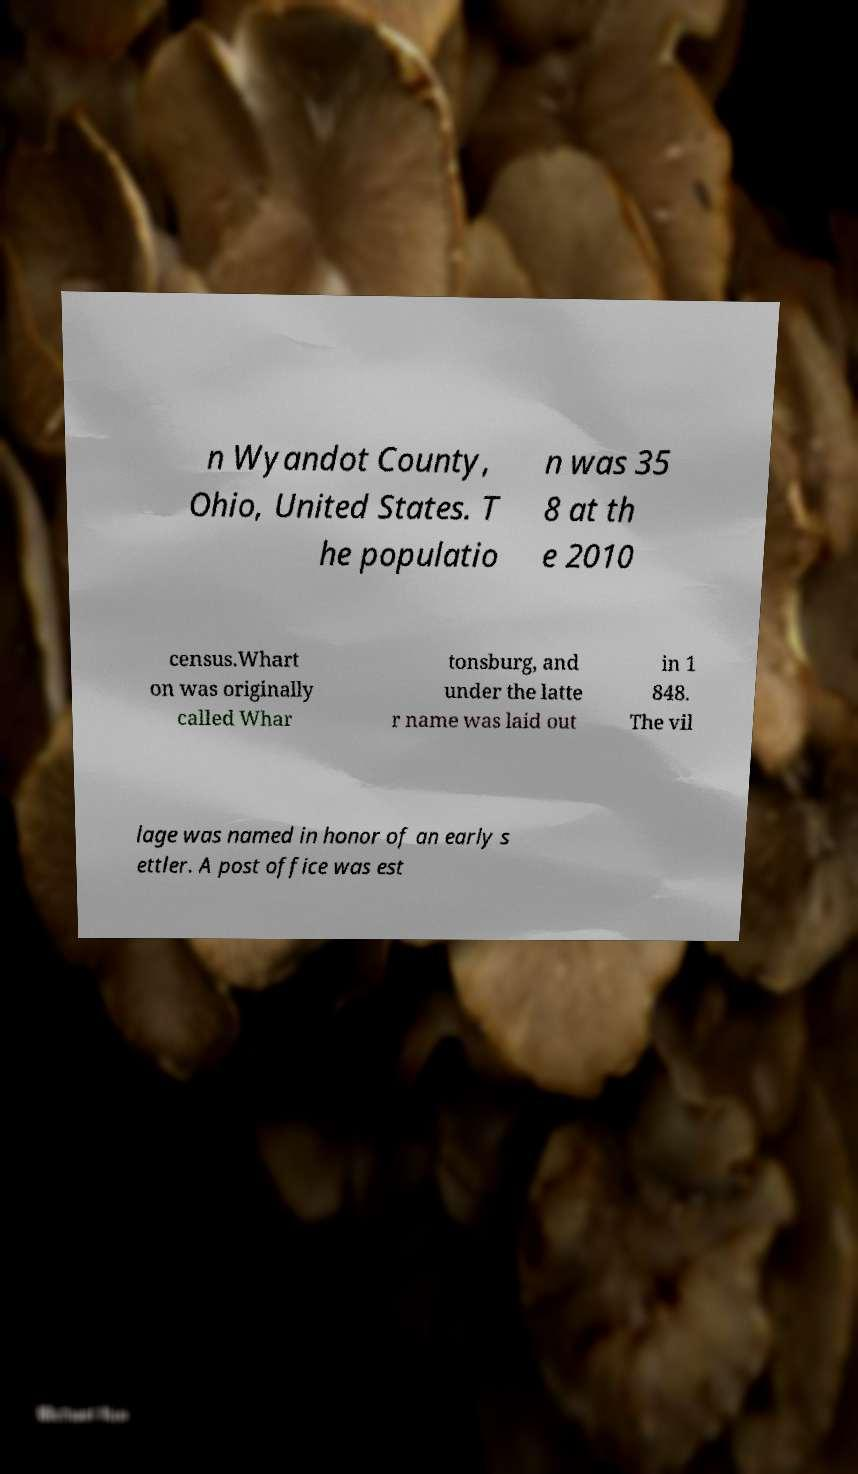Can you accurately transcribe the text from the provided image for me? n Wyandot County, Ohio, United States. T he populatio n was 35 8 at th e 2010 census.Whart on was originally called Whar tonsburg, and under the latte r name was laid out in 1 848. The vil lage was named in honor of an early s ettler. A post office was est 